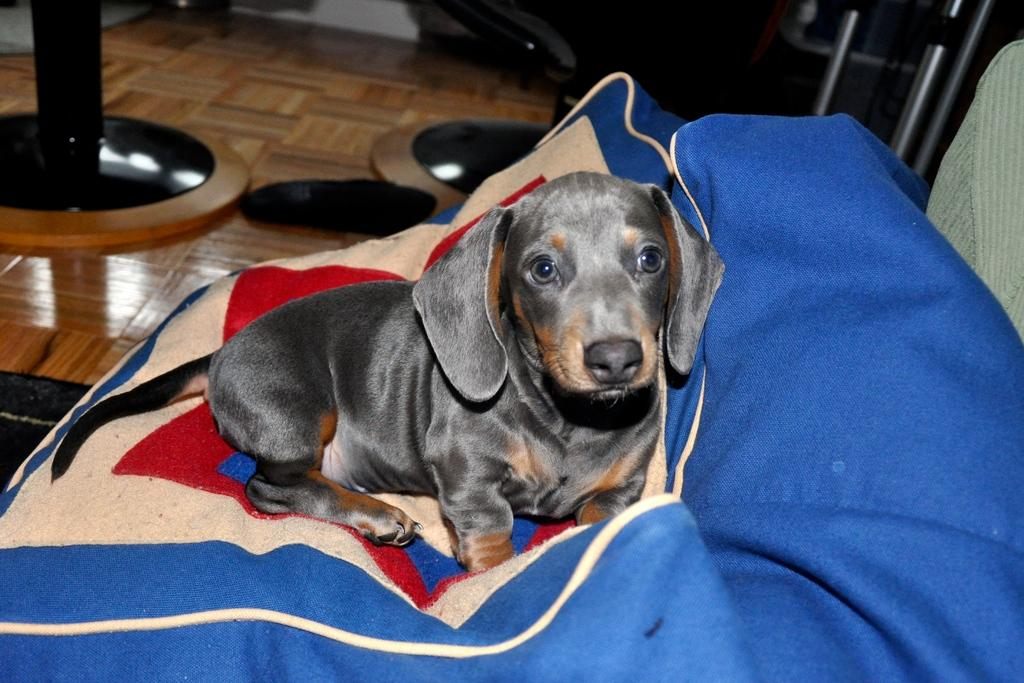What animal can be seen in the image? There is a dog in the image. Where is the dog located in the image? The dog is sitting on a couch. What type of floor is visible in the image? The floor is made of wood. What objects are on the floor in the image? There are stands on the floor. What language is the dog speaking in the image? Dogs do not speak human languages, so there is no language spoken by the dog in the image. 